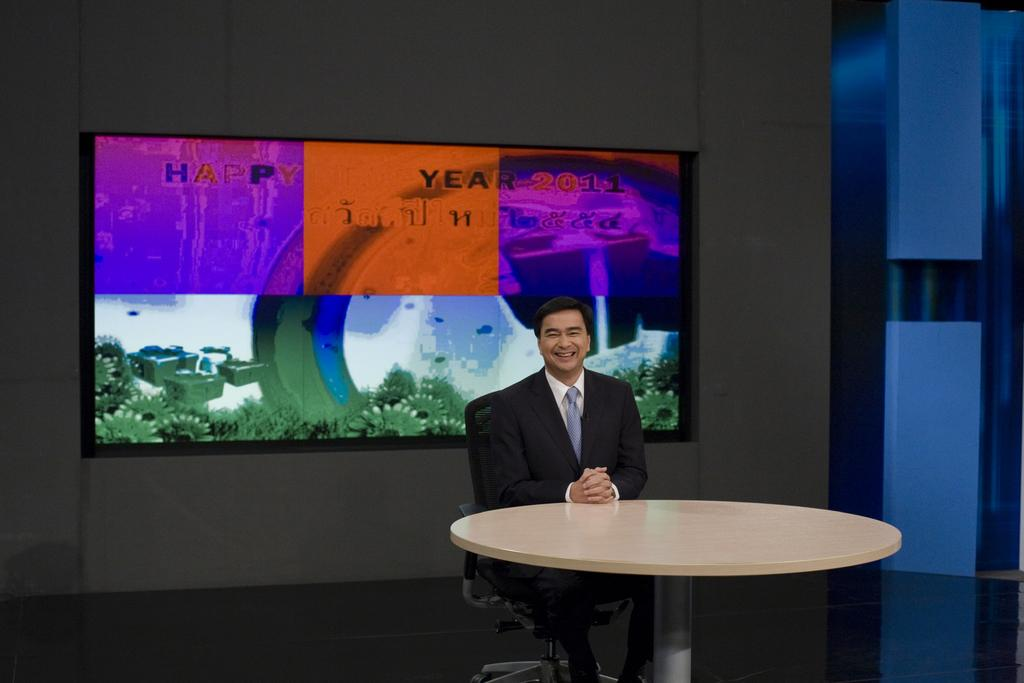What is the person in the image doing? The person is sitting on a chair in the image. What is in front of the person? The person is in front of a table. What can be seen in the background of the image? There is a wall and a television screen in the background of the image. What type of popcorn is being served on the table in the image? There is no popcorn present in the image. What tool is the person using to level the chair in the image? The person is not using any tool to level the chair in the image; they are simply sitting on it. 